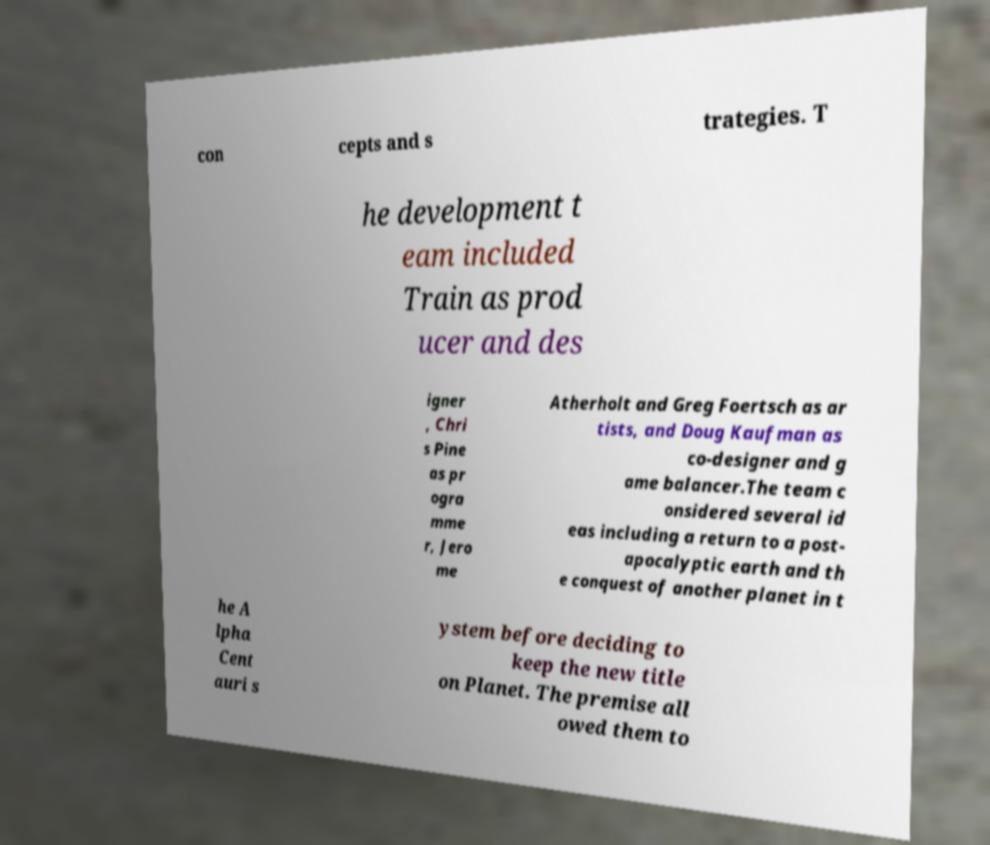Please read and relay the text visible in this image. What does it say? con cepts and s trategies. T he development t eam included Train as prod ucer and des igner , Chri s Pine as pr ogra mme r, Jero me Atherholt and Greg Foertsch as ar tists, and Doug Kaufman as co-designer and g ame balancer.The team c onsidered several id eas including a return to a post- apocalyptic earth and th e conquest of another planet in t he A lpha Cent auri s ystem before deciding to keep the new title on Planet. The premise all owed them to 